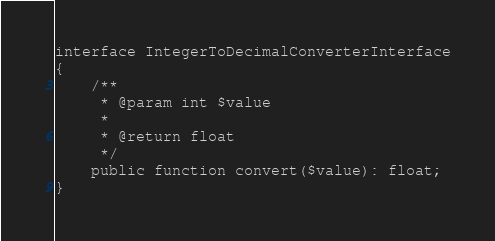Convert code to text. <code><loc_0><loc_0><loc_500><loc_500><_PHP_>
interface IntegerToDecimalConverterInterface
{
    /**
     * @param int $value
     *
     * @return float
     */
    public function convert($value): float;
}
</code> 